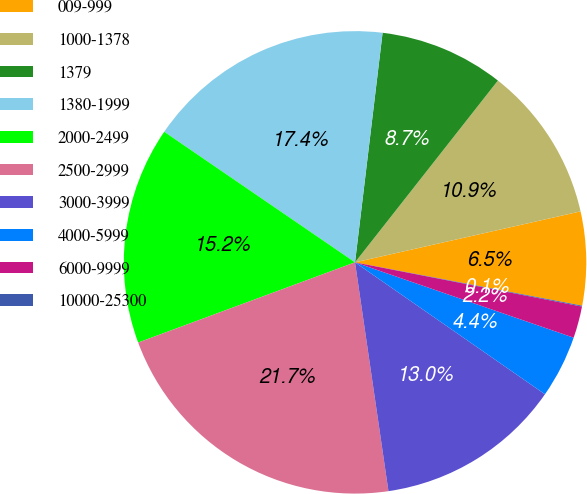<chart> <loc_0><loc_0><loc_500><loc_500><pie_chart><fcel>009-999<fcel>1000-1378<fcel>1379<fcel>1380-1999<fcel>2000-2499<fcel>2500-2999<fcel>3000-3999<fcel>4000-5999<fcel>6000-9999<fcel>10000-25300<nl><fcel>6.54%<fcel>10.86%<fcel>8.7%<fcel>17.35%<fcel>15.19%<fcel>21.67%<fcel>13.03%<fcel>4.38%<fcel>2.22%<fcel>0.06%<nl></chart> 